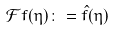Convert formula to latex. <formula><loc_0><loc_0><loc_500><loc_500>\mathcal { F } f ( \eta ) \colon = \hat { f } ( \eta )</formula> 